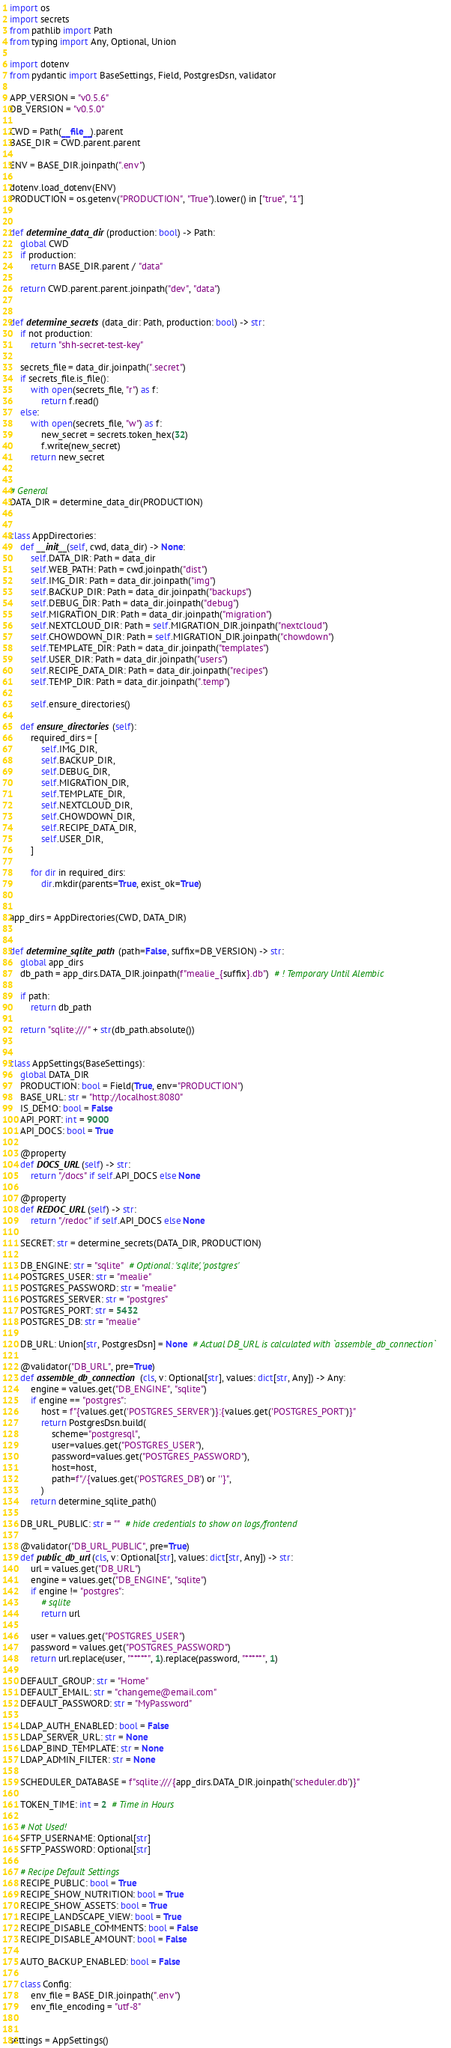<code> <loc_0><loc_0><loc_500><loc_500><_Python_>import os
import secrets
from pathlib import Path
from typing import Any, Optional, Union

import dotenv
from pydantic import BaseSettings, Field, PostgresDsn, validator

APP_VERSION = "v0.5.6"
DB_VERSION = "v0.5.0"

CWD = Path(__file__).parent
BASE_DIR = CWD.parent.parent

ENV = BASE_DIR.joinpath(".env")

dotenv.load_dotenv(ENV)
PRODUCTION = os.getenv("PRODUCTION", "True").lower() in ["true", "1"]


def determine_data_dir(production: bool) -> Path:
    global CWD
    if production:
        return BASE_DIR.parent / "data"

    return CWD.parent.parent.joinpath("dev", "data")


def determine_secrets(data_dir: Path, production: bool) -> str:
    if not production:
        return "shh-secret-test-key"

    secrets_file = data_dir.joinpath(".secret")
    if secrets_file.is_file():
        with open(secrets_file, "r") as f:
            return f.read()
    else:
        with open(secrets_file, "w") as f:
            new_secret = secrets.token_hex(32)
            f.write(new_secret)
        return new_secret


# General
DATA_DIR = determine_data_dir(PRODUCTION)


class AppDirectories:
    def __init__(self, cwd, data_dir) -> None:
        self.DATA_DIR: Path = data_dir
        self.WEB_PATH: Path = cwd.joinpath("dist")
        self.IMG_DIR: Path = data_dir.joinpath("img")
        self.BACKUP_DIR: Path = data_dir.joinpath("backups")
        self.DEBUG_DIR: Path = data_dir.joinpath("debug")
        self.MIGRATION_DIR: Path = data_dir.joinpath("migration")
        self.NEXTCLOUD_DIR: Path = self.MIGRATION_DIR.joinpath("nextcloud")
        self.CHOWDOWN_DIR: Path = self.MIGRATION_DIR.joinpath("chowdown")
        self.TEMPLATE_DIR: Path = data_dir.joinpath("templates")
        self.USER_DIR: Path = data_dir.joinpath("users")
        self.RECIPE_DATA_DIR: Path = data_dir.joinpath("recipes")
        self.TEMP_DIR: Path = data_dir.joinpath(".temp")

        self.ensure_directories()

    def ensure_directories(self):
        required_dirs = [
            self.IMG_DIR,
            self.BACKUP_DIR,
            self.DEBUG_DIR,
            self.MIGRATION_DIR,
            self.TEMPLATE_DIR,
            self.NEXTCLOUD_DIR,
            self.CHOWDOWN_DIR,
            self.RECIPE_DATA_DIR,
            self.USER_DIR,
        ]

        for dir in required_dirs:
            dir.mkdir(parents=True, exist_ok=True)


app_dirs = AppDirectories(CWD, DATA_DIR)


def determine_sqlite_path(path=False, suffix=DB_VERSION) -> str:
    global app_dirs
    db_path = app_dirs.DATA_DIR.joinpath(f"mealie_{suffix}.db")  # ! Temporary Until Alembic

    if path:
        return db_path

    return "sqlite:///" + str(db_path.absolute())


class AppSettings(BaseSettings):
    global DATA_DIR
    PRODUCTION: bool = Field(True, env="PRODUCTION")
    BASE_URL: str = "http://localhost:8080"
    IS_DEMO: bool = False
    API_PORT: int = 9000
    API_DOCS: bool = True

    @property
    def DOCS_URL(self) -> str:
        return "/docs" if self.API_DOCS else None

    @property
    def REDOC_URL(self) -> str:
        return "/redoc" if self.API_DOCS else None

    SECRET: str = determine_secrets(DATA_DIR, PRODUCTION)

    DB_ENGINE: str = "sqlite"  # Optional: 'sqlite', 'postgres'
    POSTGRES_USER: str = "mealie"
    POSTGRES_PASSWORD: str = "mealie"
    POSTGRES_SERVER: str = "postgres"
    POSTGRES_PORT: str = 5432
    POSTGRES_DB: str = "mealie"

    DB_URL: Union[str, PostgresDsn] = None  # Actual DB_URL is calculated with `assemble_db_connection`

    @validator("DB_URL", pre=True)
    def assemble_db_connection(cls, v: Optional[str], values: dict[str, Any]) -> Any:
        engine = values.get("DB_ENGINE", "sqlite")
        if engine == "postgres":
            host = f"{values.get('POSTGRES_SERVER')}:{values.get('POSTGRES_PORT')}"
            return PostgresDsn.build(
                scheme="postgresql",
                user=values.get("POSTGRES_USER"),
                password=values.get("POSTGRES_PASSWORD"),
                host=host,
                path=f"/{values.get('POSTGRES_DB') or ''}",
            )
        return determine_sqlite_path()

    DB_URL_PUBLIC: str = ""  # hide credentials to show on logs/frontend

    @validator("DB_URL_PUBLIC", pre=True)
    def public_db_url(cls, v: Optional[str], values: dict[str, Any]) -> str:
        url = values.get("DB_URL")
        engine = values.get("DB_ENGINE", "sqlite")
        if engine != "postgres":
            # sqlite
            return url

        user = values.get("POSTGRES_USER")
        password = values.get("POSTGRES_PASSWORD")
        return url.replace(user, "*****", 1).replace(password, "*****", 1)

    DEFAULT_GROUP: str = "Home"
    DEFAULT_EMAIL: str = "changeme@email.com"
    DEFAULT_PASSWORD: str = "MyPassword"

    LDAP_AUTH_ENABLED: bool = False
    LDAP_SERVER_URL: str = None
    LDAP_BIND_TEMPLATE: str = None
    LDAP_ADMIN_FILTER: str = None

    SCHEDULER_DATABASE = f"sqlite:///{app_dirs.DATA_DIR.joinpath('scheduler.db')}"

    TOKEN_TIME: int = 2  # Time in Hours

    # Not Used!
    SFTP_USERNAME: Optional[str]
    SFTP_PASSWORD: Optional[str]

    # Recipe Default Settings
    RECIPE_PUBLIC: bool = True
    RECIPE_SHOW_NUTRITION: bool = True
    RECIPE_SHOW_ASSETS: bool = True
    RECIPE_LANDSCAPE_VIEW: bool = True
    RECIPE_DISABLE_COMMENTS: bool = False
    RECIPE_DISABLE_AMOUNT: bool = False

    AUTO_BACKUP_ENABLED: bool = False

    class Config:
        env_file = BASE_DIR.joinpath(".env")
        env_file_encoding = "utf-8"


settings = AppSettings()
</code> 